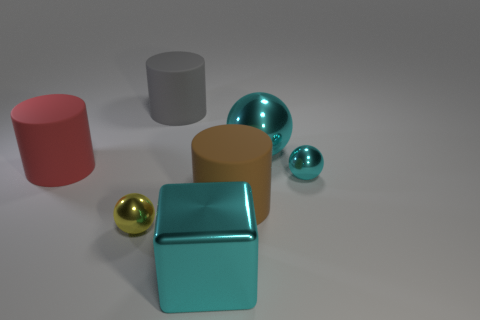What is the size of the other shiny sphere that is the same color as the big metal ball?
Your response must be concise. Small. What number of objects are small shiny things that are left of the brown rubber cylinder or large things behind the large red matte object?
Offer a very short reply. 3. There is a metallic object left of the gray object that is behind the brown thing; what is its size?
Your response must be concise. Small. The shiny cube is what size?
Offer a terse response. Large. Do the big metallic object that is to the right of the big cyan block and the tiny thing behind the brown rubber cylinder have the same color?
Offer a very short reply. Yes. What number of other objects are there of the same material as the cyan cube?
Offer a very short reply. 3. Are any large green matte spheres visible?
Keep it short and to the point. No. Is the material of the large cyan object behind the large red rubber cylinder the same as the large brown object?
Your answer should be compact. No. What material is the tiny yellow object that is the same shape as the small cyan metal object?
Give a very brief answer. Metal. What is the material of the big thing that is the same color as the big metallic cube?
Ensure brevity in your answer.  Metal. 